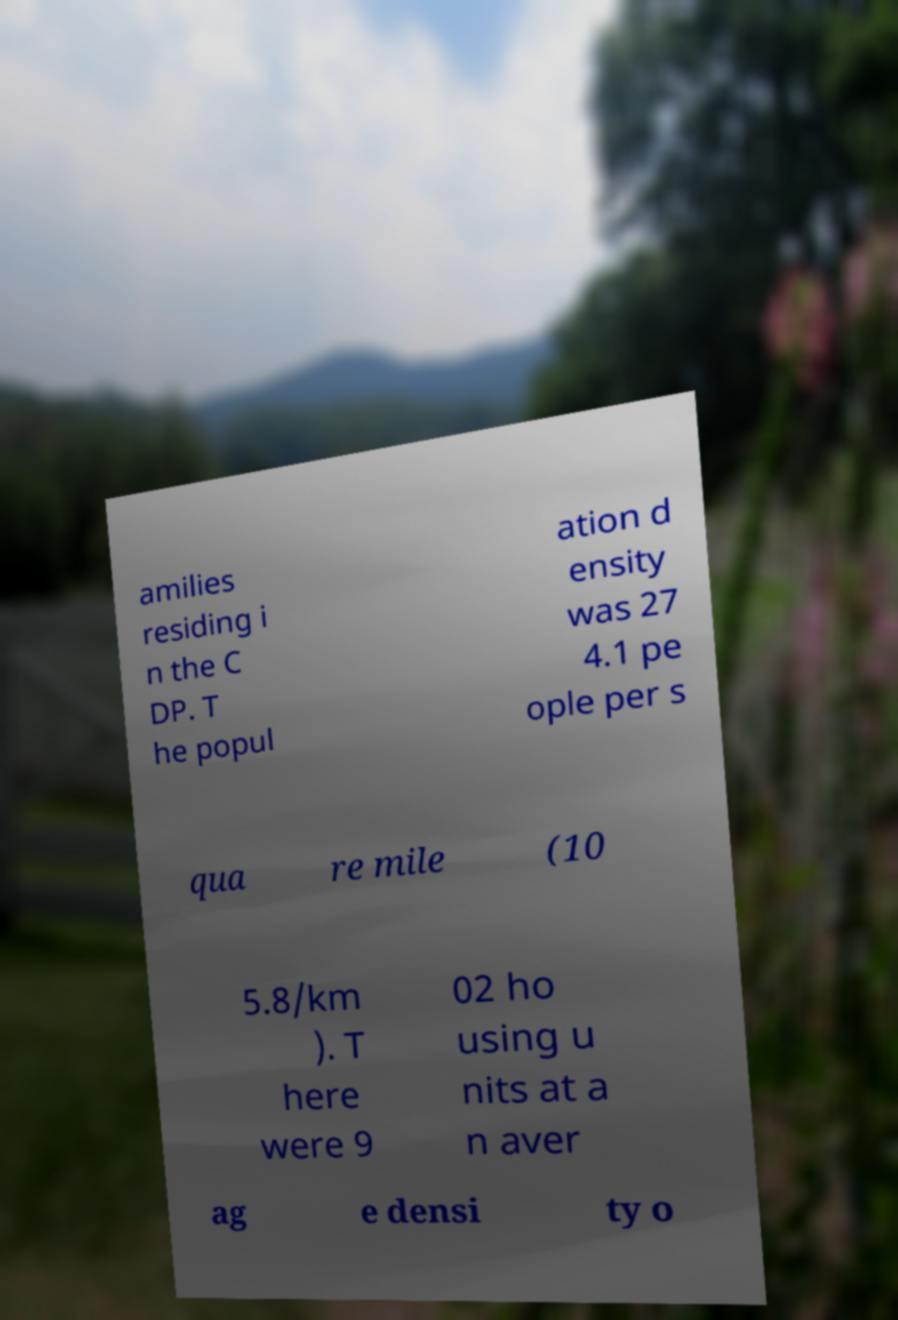I need the written content from this picture converted into text. Can you do that? amilies residing i n the C DP. T he popul ation d ensity was 27 4.1 pe ople per s qua re mile (10 5.8/km ). T here were 9 02 ho using u nits at a n aver ag e densi ty o 